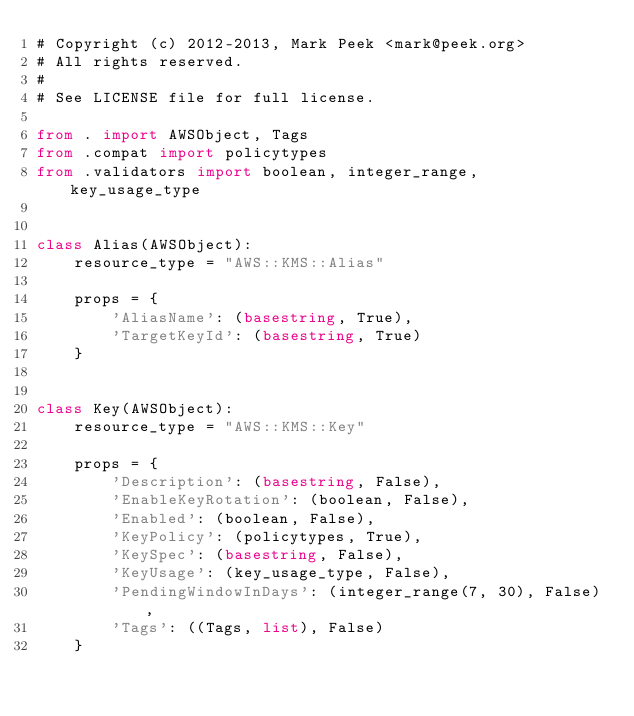<code> <loc_0><loc_0><loc_500><loc_500><_Python_># Copyright (c) 2012-2013, Mark Peek <mark@peek.org>
# All rights reserved.
#
# See LICENSE file for full license.

from . import AWSObject, Tags
from .compat import policytypes
from .validators import boolean, integer_range, key_usage_type


class Alias(AWSObject):
    resource_type = "AWS::KMS::Alias"

    props = {
        'AliasName': (basestring, True),
        'TargetKeyId': (basestring, True)
    }


class Key(AWSObject):
    resource_type = "AWS::KMS::Key"

    props = {
        'Description': (basestring, False),
        'EnableKeyRotation': (boolean, False),
        'Enabled': (boolean, False),
        'KeyPolicy': (policytypes, True),
        'KeySpec': (basestring, False),
        'KeyUsage': (key_usage_type, False),
        'PendingWindowInDays': (integer_range(7, 30), False),
        'Tags': ((Tags, list), False)
    }
</code> 